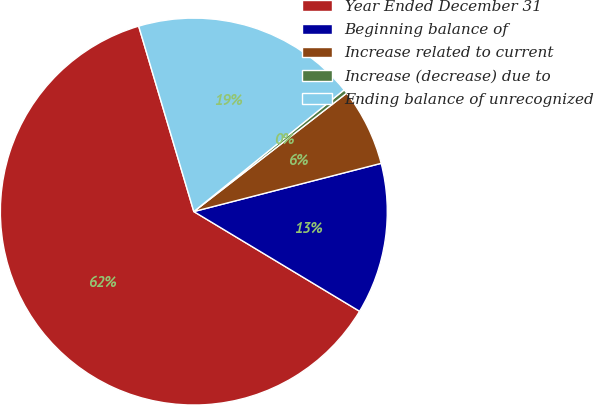<chart> <loc_0><loc_0><loc_500><loc_500><pie_chart><fcel>Year Ended December 31<fcel>Beginning balance of<fcel>Increase related to current<fcel>Increase (decrease) due to<fcel>Ending balance of unrecognized<nl><fcel>61.78%<fcel>12.63%<fcel>6.48%<fcel>0.34%<fcel>18.77%<nl></chart> 